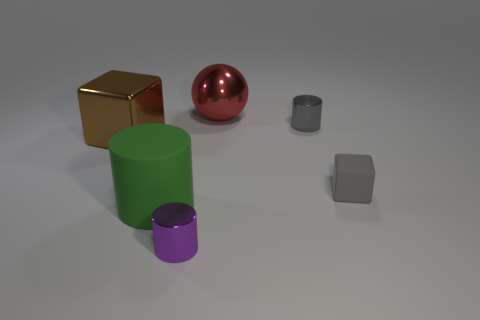Is there any pattern to the arrangement of these objects? The objects seem randomly placed without a discernible pattern. However, there's a balance in their distribution, with the larger objects spaced towards one side and the smaller ones on the opposite side, creating a sense of visual balance. Could this arrangement serve any artistic purpose? Yes, the arrangement may be designed to draw attention to certain aspects such as the contrast in sizes, the play of light on different surfaces, or the juxtaposition of vivid colors against neutral tones, which altogether can create a visually appealing composition. 